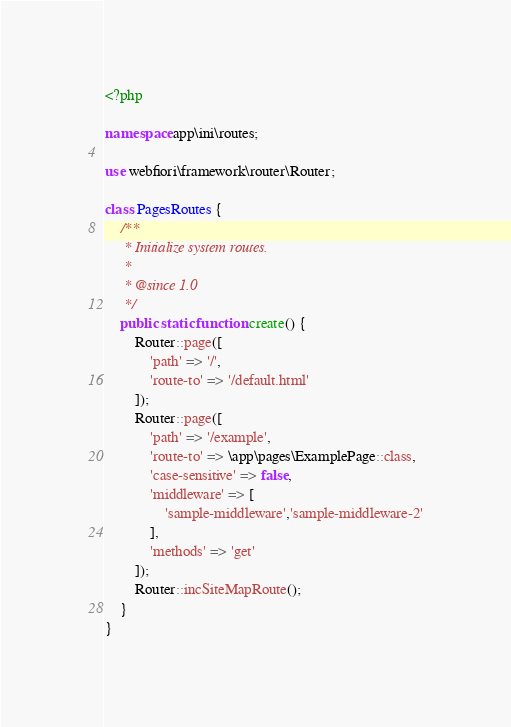<code> <loc_0><loc_0><loc_500><loc_500><_PHP_><?php

namespace app\ini\routes;

use webfiori\framework\router\Router;

class PagesRoutes {
    /**
     * Initialize system routes.
     * 
     * @since 1.0
     */
    public static function create() {
        Router::page([
            'path' => '/', 
            'route-to' => '/default.html'
        ]);
        Router::page([
            'path' => '/example', 
            'route-to' => \app\pages\ExamplePage::class,
            'case-sensitive' => false,
            'middleware' => [
                'sample-middleware','sample-middleware-2'
            ],
            'methods' => 'get'
        ]);
        Router::incSiteMapRoute();
    }
}
</code> 